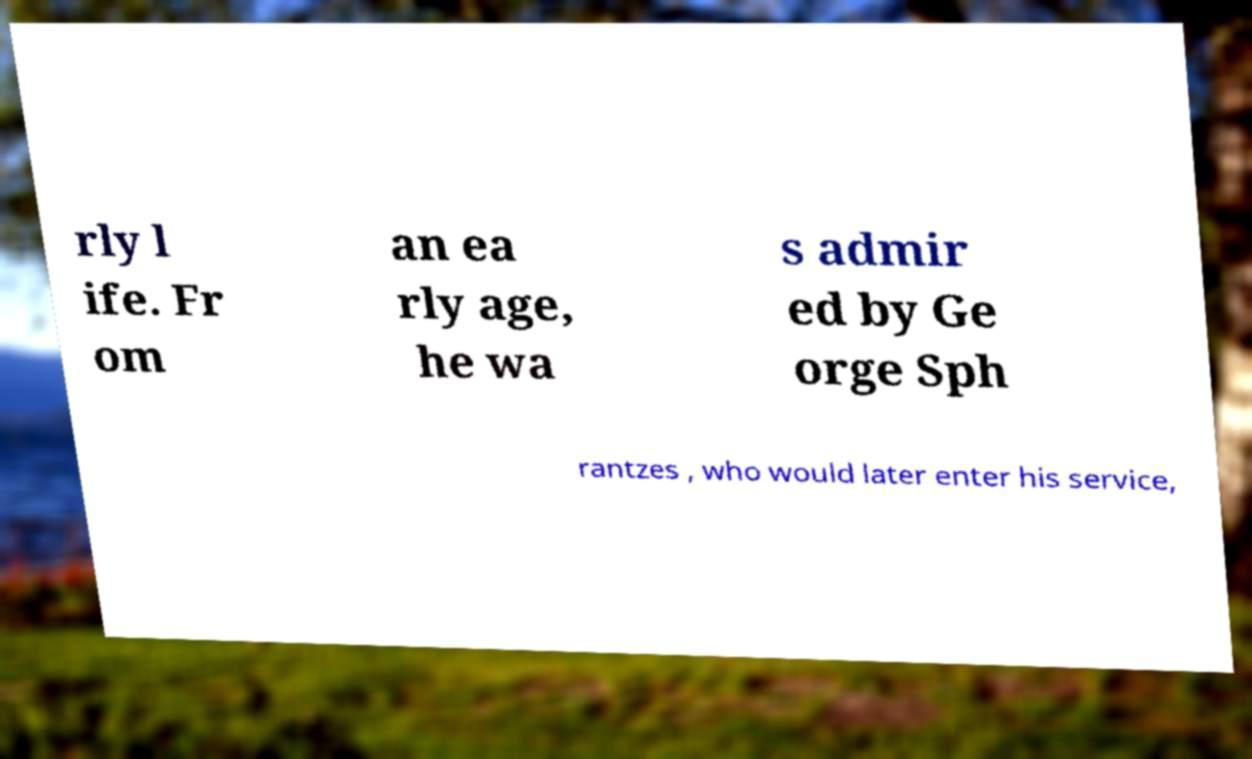Please identify and transcribe the text found in this image. rly l ife. Fr om an ea rly age, he wa s admir ed by Ge orge Sph rantzes , who would later enter his service, 